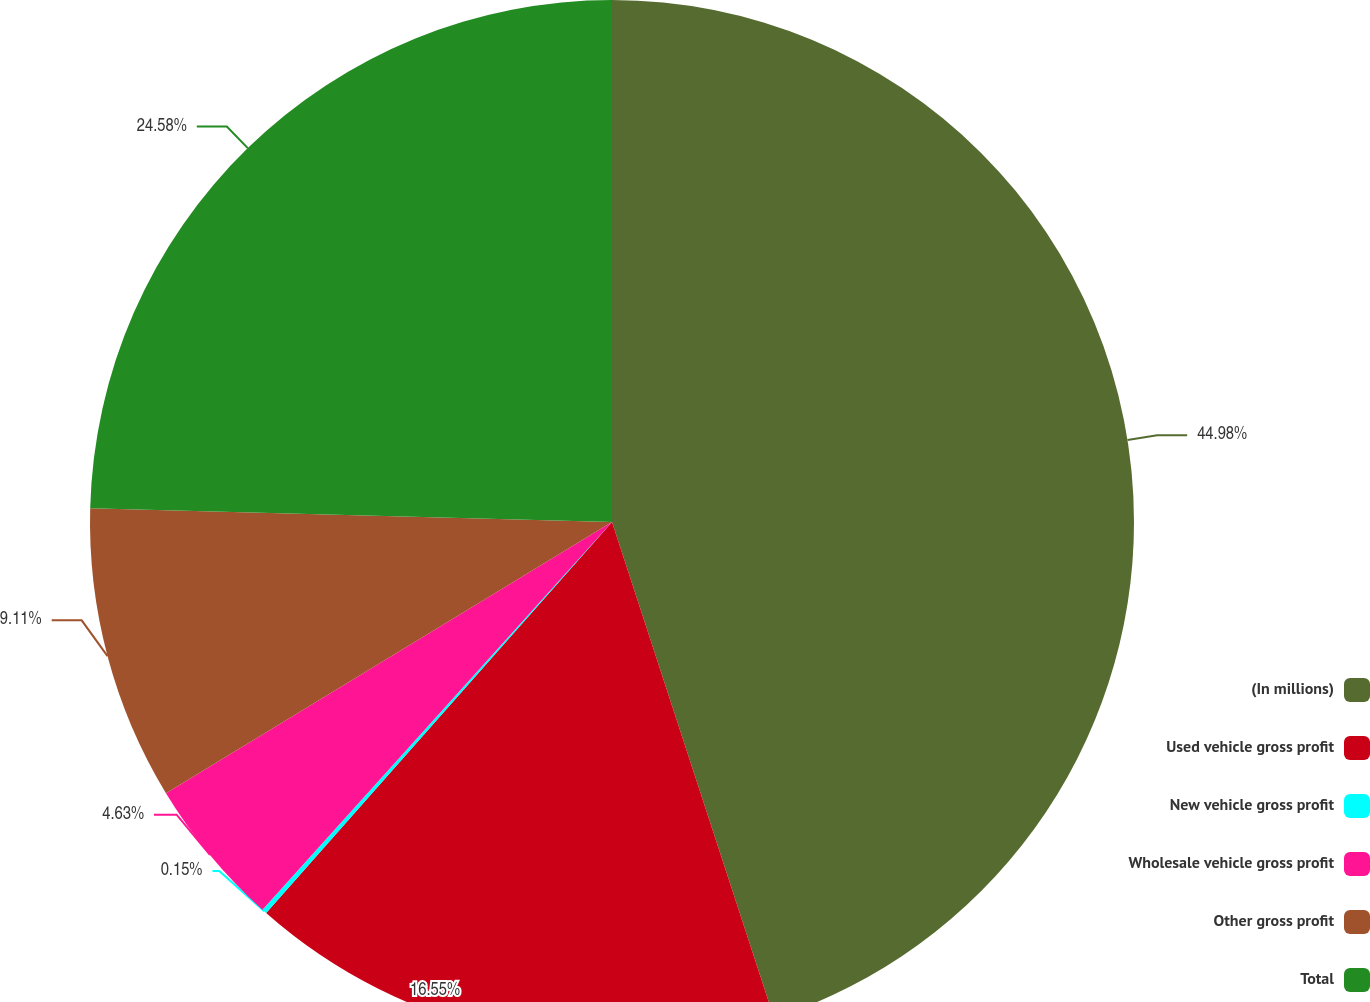Convert chart to OTSL. <chart><loc_0><loc_0><loc_500><loc_500><pie_chart><fcel>(In millions)<fcel>Used vehicle gross profit<fcel>New vehicle gross profit<fcel>Wholesale vehicle gross profit<fcel>Other gross profit<fcel>Total<nl><fcel>44.97%<fcel>16.55%<fcel>0.15%<fcel>4.63%<fcel>9.11%<fcel>24.58%<nl></chart> 